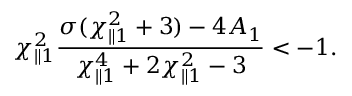Convert formula to latex. <formula><loc_0><loc_0><loc_500><loc_500>\chi _ { \| 1 } ^ { 2 } \frac { \sigma ( \chi _ { \| 1 } ^ { 2 } + 3 ) - 4 A _ { 1 } } { \chi _ { \| 1 } ^ { 4 } + 2 \chi _ { \| 1 } ^ { 2 } - 3 } < - 1 .</formula> 